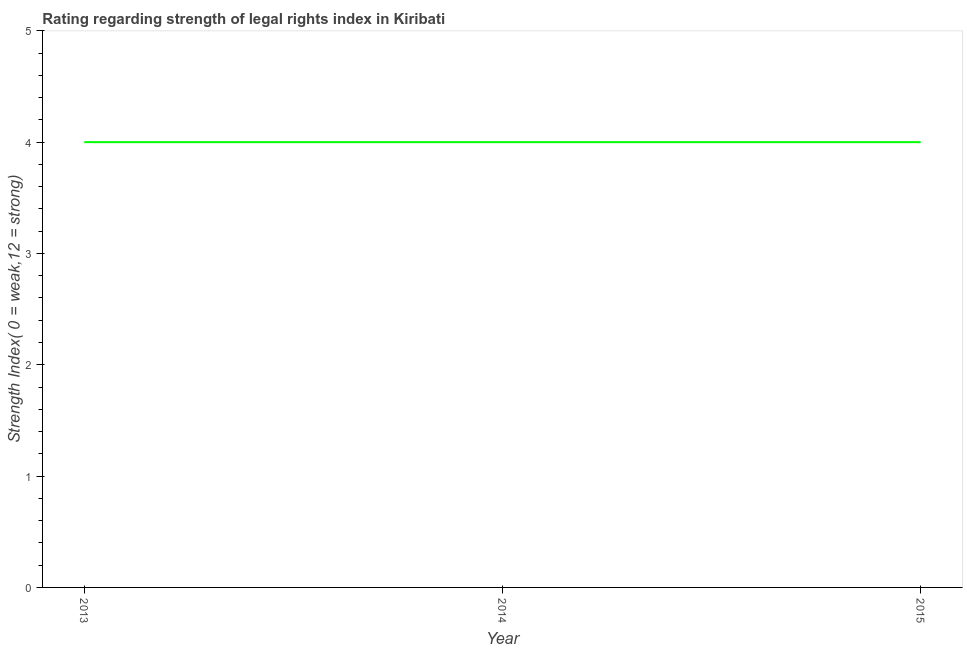What is the strength of legal rights index in 2014?
Offer a very short reply. 4. Across all years, what is the maximum strength of legal rights index?
Ensure brevity in your answer.  4. Across all years, what is the minimum strength of legal rights index?
Your answer should be compact. 4. In which year was the strength of legal rights index maximum?
Your answer should be compact. 2013. What is the sum of the strength of legal rights index?
Ensure brevity in your answer.  12. What is the average strength of legal rights index per year?
Ensure brevity in your answer.  4. In how many years, is the strength of legal rights index greater than 3.4 ?
Provide a succinct answer. 3. What is the ratio of the strength of legal rights index in 2014 to that in 2015?
Your answer should be compact. 1. Is the difference between the strength of legal rights index in 2014 and 2015 greater than the difference between any two years?
Provide a short and direct response. Yes. What is the difference between the highest and the second highest strength of legal rights index?
Provide a succinct answer. 0. What is the difference between the highest and the lowest strength of legal rights index?
Your response must be concise. 0. In how many years, is the strength of legal rights index greater than the average strength of legal rights index taken over all years?
Your answer should be compact. 0. Does the strength of legal rights index monotonically increase over the years?
Your answer should be compact. No. How many lines are there?
Offer a very short reply. 1. What is the difference between two consecutive major ticks on the Y-axis?
Provide a short and direct response. 1. What is the title of the graph?
Your answer should be very brief. Rating regarding strength of legal rights index in Kiribati. What is the label or title of the Y-axis?
Make the answer very short. Strength Index( 0 = weak,12 = strong). What is the Strength Index( 0 = weak,12 = strong) of 2013?
Provide a succinct answer. 4. What is the Strength Index( 0 = weak,12 = strong) in 2014?
Your answer should be very brief. 4. What is the difference between the Strength Index( 0 = weak,12 = strong) in 2013 and 2014?
Make the answer very short. 0. What is the difference between the Strength Index( 0 = weak,12 = strong) in 2013 and 2015?
Ensure brevity in your answer.  0. What is the ratio of the Strength Index( 0 = weak,12 = strong) in 2013 to that in 2014?
Ensure brevity in your answer.  1. What is the ratio of the Strength Index( 0 = weak,12 = strong) in 2013 to that in 2015?
Your response must be concise. 1. What is the ratio of the Strength Index( 0 = weak,12 = strong) in 2014 to that in 2015?
Offer a terse response. 1. 